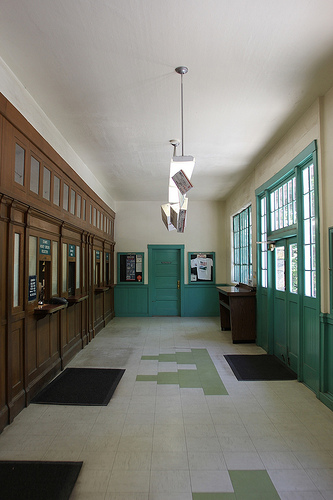<image>
Is there a door under the light? Yes. The door is positioned underneath the light, with the light above it in the vertical space. 